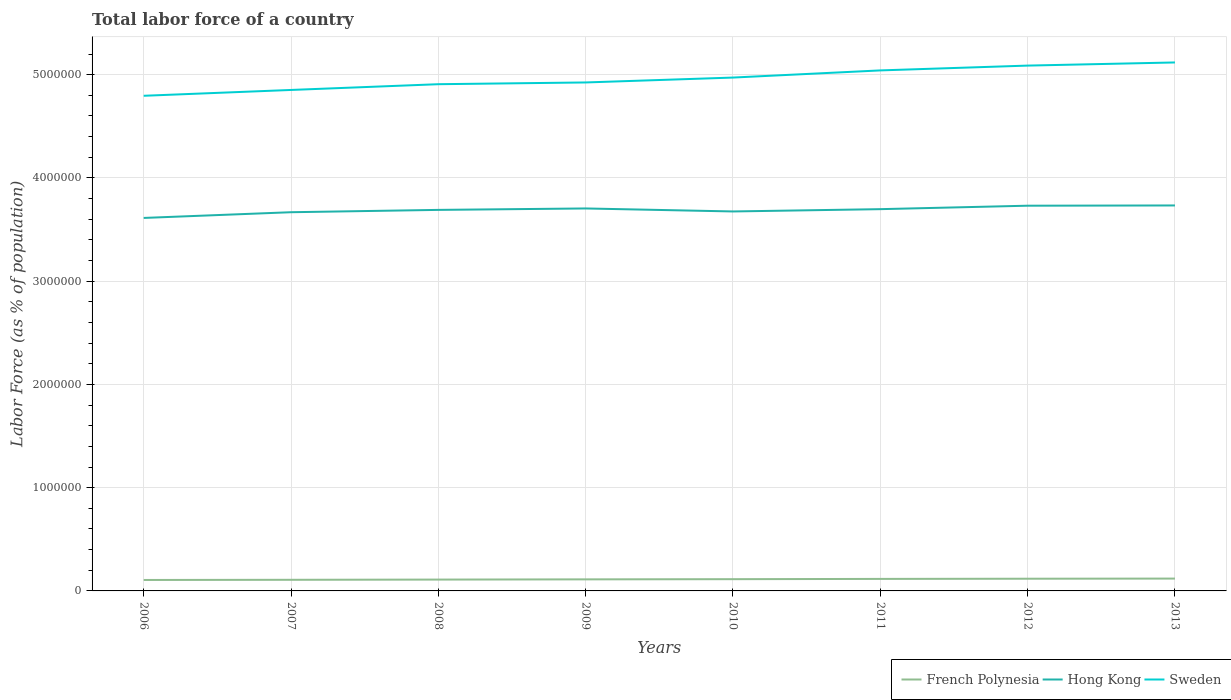How many different coloured lines are there?
Your response must be concise. 3. Does the line corresponding to French Polynesia intersect with the line corresponding to Sweden?
Provide a short and direct response. No. Across all years, what is the maximum percentage of labor force in French Polynesia?
Your response must be concise. 1.06e+05. What is the total percentage of labor force in Hong Kong in the graph?
Make the answer very short. -2.21e+04. What is the difference between the highest and the second highest percentage of labor force in French Polynesia?
Your response must be concise. 1.34e+04. Is the percentage of labor force in Sweden strictly greater than the percentage of labor force in French Polynesia over the years?
Give a very brief answer. No. Does the graph contain any zero values?
Provide a short and direct response. No. Does the graph contain grids?
Offer a terse response. Yes. Where does the legend appear in the graph?
Give a very brief answer. Bottom right. What is the title of the graph?
Provide a short and direct response. Total labor force of a country. What is the label or title of the Y-axis?
Give a very brief answer. Labor Force (as % of population). What is the Labor Force (as % of population) of French Polynesia in 2006?
Your answer should be very brief. 1.06e+05. What is the Labor Force (as % of population) of Hong Kong in 2006?
Your response must be concise. 3.61e+06. What is the Labor Force (as % of population) in Sweden in 2006?
Provide a short and direct response. 4.80e+06. What is the Labor Force (as % of population) in French Polynesia in 2007?
Ensure brevity in your answer.  1.08e+05. What is the Labor Force (as % of population) of Hong Kong in 2007?
Your response must be concise. 3.67e+06. What is the Labor Force (as % of population) of Sweden in 2007?
Give a very brief answer. 4.85e+06. What is the Labor Force (as % of population) of French Polynesia in 2008?
Offer a very short reply. 1.10e+05. What is the Labor Force (as % of population) in Hong Kong in 2008?
Provide a short and direct response. 3.69e+06. What is the Labor Force (as % of population) in Sweden in 2008?
Make the answer very short. 4.91e+06. What is the Labor Force (as % of population) of French Polynesia in 2009?
Your answer should be very brief. 1.12e+05. What is the Labor Force (as % of population) in Hong Kong in 2009?
Provide a short and direct response. 3.70e+06. What is the Labor Force (as % of population) of Sweden in 2009?
Provide a succinct answer. 4.92e+06. What is the Labor Force (as % of population) in French Polynesia in 2010?
Keep it short and to the point. 1.14e+05. What is the Labor Force (as % of population) of Hong Kong in 2010?
Make the answer very short. 3.68e+06. What is the Labor Force (as % of population) of Sweden in 2010?
Your answer should be very brief. 4.97e+06. What is the Labor Force (as % of population) of French Polynesia in 2011?
Your answer should be very brief. 1.16e+05. What is the Labor Force (as % of population) in Hong Kong in 2011?
Offer a very short reply. 3.70e+06. What is the Labor Force (as % of population) in Sweden in 2011?
Provide a short and direct response. 5.04e+06. What is the Labor Force (as % of population) of French Polynesia in 2012?
Provide a succinct answer. 1.18e+05. What is the Labor Force (as % of population) in Hong Kong in 2012?
Your answer should be compact. 3.73e+06. What is the Labor Force (as % of population) in Sweden in 2012?
Provide a short and direct response. 5.09e+06. What is the Labor Force (as % of population) of French Polynesia in 2013?
Provide a succinct answer. 1.20e+05. What is the Labor Force (as % of population) in Hong Kong in 2013?
Your answer should be very brief. 3.73e+06. What is the Labor Force (as % of population) in Sweden in 2013?
Provide a short and direct response. 5.12e+06. Across all years, what is the maximum Labor Force (as % of population) of French Polynesia?
Provide a succinct answer. 1.20e+05. Across all years, what is the maximum Labor Force (as % of population) in Hong Kong?
Give a very brief answer. 3.73e+06. Across all years, what is the maximum Labor Force (as % of population) of Sweden?
Provide a short and direct response. 5.12e+06. Across all years, what is the minimum Labor Force (as % of population) in French Polynesia?
Make the answer very short. 1.06e+05. Across all years, what is the minimum Labor Force (as % of population) in Hong Kong?
Provide a succinct answer. 3.61e+06. Across all years, what is the minimum Labor Force (as % of population) of Sweden?
Offer a terse response. 4.80e+06. What is the total Labor Force (as % of population) of French Polynesia in the graph?
Give a very brief answer. 9.04e+05. What is the total Labor Force (as % of population) of Hong Kong in the graph?
Your answer should be compact. 2.95e+07. What is the total Labor Force (as % of population) in Sweden in the graph?
Make the answer very short. 3.97e+07. What is the difference between the Labor Force (as % of population) in French Polynesia in 2006 and that in 2007?
Provide a short and direct response. -1577. What is the difference between the Labor Force (as % of population) in Hong Kong in 2006 and that in 2007?
Provide a short and direct response. -5.53e+04. What is the difference between the Labor Force (as % of population) of Sweden in 2006 and that in 2007?
Your answer should be compact. -5.64e+04. What is the difference between the Labor Force (as % of population) of French Polynesia in 2006 and that in 2008?
Offer a terse response. -3762. What is the difference between the Labor Force (as % of population) in Hong Kong in 2006 and that in 2008?
Offer a terse response. -7.80e+04. What is the difference between the Labor Force (as % of population) of Sweden in 2006 and that in 2008?
Your response must be concise. -1.12e+05. What is the difference between the Labor Force (as % of population) in French Polynesia in 2006 and that in 2009?
Ensure brevity in your answer.  -5846. What is the difference between the Labor Force (as % of population) in Hong Kong in 2006 and that in 2009?
Your response must be concise. -9.18e+04. What is the difference between the Labor Force (as % of population) in Sweden in 2006 and that in 2009?
Your response must be concise. -1.29e+05. What is the difference between the Labor Force (as % of population) in French Polynesia in 2006 and that in 2010?
Provide a short and direct response. -7704. What is the difference between the Labor Force (as % of population) of Hong Kong in 2006 and that in 2010?
Provide a short and direct response. -6.29e+04. What is the difference between the Labor Force (as % of population) in Sweden in 2006 and that in 2010?
Keep it short and to the point. -1.76e+05. What is the difference between the Labor Force (as % of population) in French Polynesia in 2006 and that in 2011?
Ensure brevity in your answer.  -1.03e+04. What is the difference between the Labor Force (as % of population) of Hong Kong in 2006 and that in 2011?
Offer a terse response. -8.50e+04. What is the difference between the Labor Force (as % of population) in Sweden in 2006 and that in 2011?
Your answer should be compact. -2.46e+05. What is the difference between the Labor Force (as % of population) of French Polynesia in 2006 and that in 2012?
Offer a very short reply. -1.20e+04. What is the difference between the Labor Force (as % of population) of Hong Kong in 2006 and that in 2012?
Give a very brief answer. -1.18e+05. What is the difference between the Labor Force (as % of population) of Sweden in 2006 and that in 2012?
Give a very brief answer. -2.92e+05. What is the difference between the Labor Force (as % of population) of French Polynesia in 2006 and that in 2013?
Offer a very short reply. -1.34e+04. What is the difference between the Labor Force (as % of population) in Hong Kong in 2006 and that in 2013?
Provide a succinct answer. -1.21e+05. What is the difference between the Labor Force (as % of population) of Sweden in 2006 and that in 2013?
Make the answer very short. -3.23e+05. What is the difference between the Labor Force (as % of population) of French Polynesia in 2007 and that in 2008?
Your answer should be compact. -2185. What is the difference between the Labor Force (as % of population) in Hong Kong in 2007 and that in 2008?
Ensure brevity in your answer.  -2.26e+04. What is the difference between the Labor Force (as % of population) of Sweden in 2007 and that in 2008?
Give a very brief answer. -5.57e+04. What is the difference between the Labor Force (as % of population) of French Polynesia in 2007 and that in 2009?
Give a very brief answer. -4269. What is the difference between the Labor Force (as % of population) in Hong Kong in 2007 and that in 2009?
Your response must be concise. -3.65e+04. What is the difference between the Labor Force (as % of population) of Sweden in 2007 and that in 2009?
Provide a succinct answer. -7.26e+04. What is the difference between the Labor Force (as % of population) of French Polynesia in 2007 and that in 2010?
Offer a terse response. -6127. What is the difference between the Labor Force (as % of population) in Hong Kong in 2007 and that in 2010?
Your answer should be very brief. -7529. What is the difference between the Labor Force (as % of population) of Sweden in 2007 and that in 2010?
Offer a very short reply. -1.20e+05. What is the difference between the Labor Force (as % of population) of French Polynesia in 2007 and that in 2011?
Your response must be concise. -8724. What is the difference between the Labor Force (as % of population) of Hong Kong in 2007 and that in 2011?
Give a very brief answer. -2.97e+04. What is the difference between the Labor Force (as % of population) in Sweden in 2007 and that in 2011?
Your answer should be very brief. -1.89e+05. What is the difference between the Labor Force (as % of population) of French Polynesia in 2007 and that in 2012?
Your answer should be very brief. -1.05e+04. What is the difference between the Labor Force (as % of population) of Hong Kong in 2007 and that in 2012?
Your answer should be compact. -6.31e+04. What is the difference between the Labor Force (as % of population) in Sweden in 2007 and that in 2012?
Offer a very short reply. -2.36e+05. What is the difference between the Labor Force (as % of population) in French Polynesia in 2007 and that in 2013?
Offer a terse response. -1.18e+04. What is the difference between the Labor Force (as % of population) in Hong Kong in 2007 and that in 2013?
Keep it short and to the point. -6.55e+04. What is the difference between the Labor Force (as % of population) in Sweden in 2007 and that in 2013?
Keep it short and to the point. -2.66e+05. What is the difference between the Labor Force (as % of population) in French Polynesia in 2008 and that in 2009?
Offer a very short reply. -2084. What is the difference between the Labor Force (as % of population) in Hong Kong in 2008 and that in 2009?
Ensure brevity in your answer.  -1.39e+04. What is the difference between the Labor Force (as % of population) of Sweden in 2008 and that in 2009?
Ensure brevity in your answer.  -1.69e+04. What is the difference between the Labor Force (as % of population) in French Polynesia in 2008 and that in 2010?
Provide a short and direct response. -3942. What is the difference between the Labor Force (as % of population) in Hong Kong in 2008 and that in 2010?
Offer a very short reply. 1.51e+04. What is the difference between the Labor Force (as % of population) of Sweden in 2008 and that in 2010?
Give a very brief answer. -6.44e+04. What is the difference between the Labor Force (as % of population) of French Polynesia in 2008 and that in 2011?
Keep it short and to the point. -6539. What is the difference between the Labor Force (as % of population) in Hong Kong in 2008 and that in 2011?
Provide a succinct answer. -7041. What is the difference between the Labor Force (as % of population) in Sweden in 2008 and that in 2011?
Your answer should be very brief. -1.34e+05. What is the difference between the Labor Force (as % of population) in French Polynesia in 2008 and that in 2012?
Give a very brief answer. -8269. What is the difference between the Labor Force (as % of population) in Hong Kong in 2008 and that in 2012?
Give a very brief answer. -4.05e+04. What is the difference between the Labor Force (as % of population) in Sweden in 2008 and that in 2012?
Your response must be concise. -1.80e+05. What is the difference between the Labor Force (as % of population) of French Polynesia in 2008 and that in 2013?
Your response must be concise. -9644. What is the difference between the Labor Force (as % of population) in Hong Kong in 2008 and that in 2013?
Your response must be concise. -4.29e+04. What is the difference between the Labor Force (as % of population) of Sweden in 2008 and that in 2013?
Make the answer very short. -2.11e+05. What is the difference between the Labor Force (as % of population) of French Polynesia in 2009 and that in 2010?
Make the answer very short. -1858. What is the difference between the Labor Force (as % of population) in Hong Kong in 2009 and that in 2010?
Your answer should be very brief. 2.90e+04. What is the difference between the Labor Force (as % of population) in Sweden in 2009 and that in 2010?
Your answer should be very brief. -4.74e+04. What is the difference between the Labor Force (as % of population) of French Polynesia in 2009 and that in 2011?
Offer a very short reply. -4455. What is the difference between the Labor Force (as % of population) in Hong Kong in 2009 and that in 2011?
Provide a succinct answer. 6847. What is the difference between the Labor Force (as % of population) in Sweden in 2009 and that in 2011?
Offer a very short reply. -1.17e+05. What is the difference between the Labor Force (as % of population) in French Polynesia in 2009 and that in 2012?
Make the answer very short. -6185. What is the difference between the Labor Force (as % of population) in Hong Kong in 2009 and that in 2012?
Make the answer very short. -2.66e+04. What is the difference between the Labor Force (as % of population) of Sweden in 2009 and that in 2012?
Your answer should be compact. -1.63e+05. What is the difference between the Labor Force (as % of population) in French Polynesia in 2009 and that in 2013?
Give a very brief answer. -7560. What is the difference between the Labor Force (as % of population) in Hong Kong in 2009 and that in 2013?
Make the answer very short. -2.90e+04. What is the difference between the Labor Force (as % of population) of Sweden in 2009 and that in 2013?
Keep it short and to the point. -1.94e+05. What is the difference between the Labor Force (as % of population) of French Polynesia in 2010 and that in 2011?
Ensure brevity in your answer.  -2597. What is the difference between the Labor Force (as % of population) of Hong Kong in 2010 and that in 2011?
Your answer should be very brief. -2.21e+04. What is the difference between the Labor Force (as % of population) in Sweden in 2010 and that in 2011?
Provide a succinct answer. -6.93e+04. What is the difference between the Labor Force (as % of population) of French Polynesia in 2010 and that in 2012?
Provide a short and direct response. -4327. What is the difference between the Labor Force (as % of population) of Hong Kong in 2010 and that in 2012?
Provide a short and direct response. -5.56e+04. What is the difference between the Labor Force (as % of population) of Sweden in 2010 and that in 2012?
Offer a terse response. -1.16e+05. What is the difference between the Labor Force (as % of population) in French Polynesia in 2010 and that in 2013?
Provide a succinct answer. -5702. What is the difference between the Labor Force (as % of population) of Hong Kong in 2010 and that in 2013?
Keep it short and to the point. -5.80e+04. What is the difference between the Labor Force (as % of population) of Sweden in 2010 and that in 2013?
Make the answer very short. -1.46e+05. What is the difference between the Labor Force (as % of population) in French Polynesia in 2011 and that in 2012?
Your answer should be compact. -1730. What is the difference between the Labor Force (as % of population) in Hong Kong in 2011 and that in 2012?
Offer a very short reply. -3.34e+04. What is the difference between the Labor Force (as % of population) in Sweden in 2011 and that in 2012?
Provide a short and direct response. -4.66e+04. What is the difference between the Labor Force (as % of population) in French Polynesia in 2011 and that in 2013?
Ensure brevity in your answer.  -3105. What is the difference between the Labor Force (as % of population) of Hong Kong in 2011 and that in 2013?
Give a very brief answer. -3.59e+04. What is the difference between the Labor Force (as % of population) of Sweden in 2011 and that in 2013?
Ensure brevity in your answer.  -7.70e+04. What is the difference between the Labor Force (as % of population) in French Polynesia in 2012 and that in 2013?
Offer a very short reply. -1375. What is the difference between the Labor Force (as % of population) in Hong Kong in 2012 and that in 2013?
Provide a short and direct response. -2418. What is the difference between the Labor Force (as % of population) in Sweden in 2012 and that in 2013?
Offer a terse response. -3.05e+04. What is the difference between the Labor Force (as % of population) in French Polynesia in 2006 and the Labor Force (as % of population) in Hong Kong in 2007?
Keep it short and to the point. -3.56e+06. What is the difference between the Labor Force (as % of population) of French Polynesia in 2006 and the Labor Force (as % of population) of Sweden in 2007?
Offer a terse response. -4.75e+06. What is the difference between the Labor Force (as % of population) in Hong Kong in 2006 and the Labor Force (as % of population) in Sweden in 2007?
Offer a terse response. -1.24e+06. What is the difference between the Labor Force (as % of population) of French Polynesia in 2006 and the Labor Force (as % of population) of Hong Kong in 2008?
Provide a succinct answer. -3.58e+06. What is the difference between the Labor Force (as % of population) in French Polynesia in 2006 and the Labor Force (as % of population) in Sweden in 2008?
Ensure brevity in your answer.  -4.80e+06. What is the difference between the Labor Force (as % of population) in Hong Kong in 2006 and the Labor Force (as % of population) in Sweden in 2008?
Give a very brief answer. -1.30e+06. What is the difference between the Labor Force (as % of population) in French Polynesia in 2006 and the Labor Force (as % of population) in Hong Kong in 2009?
Your response must be concise. -3.60e+06. What is the difference between the Labor Force (as % of population) of French Polynesia in 2006 and the Labor Force (as % of population) of Sweden in 2009?
Give a very brief answer. -4.82e+06. What is the difference between the Labor Force (as % of population) in Hong Kong in 2006 and the Labor Force (as % of population) in Sweden in 2009?
Give a very brief answer. -1.31e+06. What is the difference between the Labor Force (as % of population) of French Polynesia in 2006 and the Labor Force (as % of population) of Hong Kong in 2010?
Your response must be concise. -3.57e+06. What is the difference between the Labor Force (as % of population) of French Polynesia in 2006 and the Labor Force (as % of population) of Sweden in 2010?
Your answer should be compact. -4.87e+06. What is the difference between the Labor Force (as % of population) in Hong Kong in 2006 and the Labor Force (as % of population) in Sweden in 2010?
Keep it short and to the point. -1.36e+06. What is the difference between the Labor Force (as % of population) of French Polynesia in 2006 and the Labor Force (as % of population) of Hong Kong in 2011?
Your answer should be compact. -3.59e+06. What is the difference between the Labor Force (as % of population) of French Polynesia in 2006 and the Labor Force (as % of population) of Sweden in 2011?
Keep it short and to the point. -4.94e+06. What is the difference between the Labor Force (as % of population) of Hong Kong in 2006 and the Labor Force (as % of population) of Sweden in 2011?
Offer a terse response. -1.43e+06. What is the difference between the Labor Force (as % of population) in French Polynesia in 2006 and the Labor Force (as % of population) in Hong Kong in 2012?
Your answer should be very brief. -3.62e+06. What is the difference between the Labor Force (as % of population) of French Polynesia in 2006 and the Labor Force (as % of population) of Sweden in 2012?
Make the answer very short. -4.98e+06. What is the difference between the Labor Force (as % of population) of Hong Kong in 2006 and the Labor Force (as % of population) of Sweden in 2012?
Make the answer very short. -1.48e+06. What is the difference between the Labor Force (as % of population) of French Polynesia in 2006 and the Labor Force (as % of population) of Hong Kong in 2013?
Ensure brevity in your answer.  -3.63e+06. What is the difference between the Labor Force (as % of population) in French Polynesia in 2006 and the Labor Force (as % of population) in Sweden in 2013?
Offer a very short reply. -5.01e+06. What is the difference between the Labor Force (as % of population) in Hong Kong in 2006 and the Labor Force (as % of population) in Sweden in 2013?
Make the answer very short. -1.51e+06. What is the difference between the Labor Force (as % of population) in French Polynesia in 2007 and the Labor Force (as % of population) in Hong Kong in 2008?
Give a very brief answer. -3.58e+06. What is the difference between the Labor Force (as % of population) in French Polynesia in 2007 and the Labor Force (as % of population) in Sweden in 2008?
Make the answer very short. -4.80e+06. What is the difference between the Labor Force (as % of population) of Hong Kong in 2007 and the Labor Force (as % of population) of Sweden in 2008?
Keep it short and to the point. -1.24e+06. What is the difference between the Labor Force (as % of population) in French Polynesia in 2007 and the Labor Force (as % of population) in Hong Kong in 2009?
Make the answer very short. -3.60e+06. What is the difference between the Labor Force (as % of population) of French Polynesia in 2007 and the Labor Force (as % of population) of Sweden in 2009?
Ensure brevity in your answer.  -4.82e+06. What is the difference between the Labor Force (as % of population) of Hong Kong in 2007 and the Labor Force (as % of population) of Sweden in 2009?
Offer a terse response. -1.26e+06. What is the difference between the Labor Force (as % of population) of French Polynesia in 2007 and the Labor Force (as % of population) of Hong Kong in 2010?
Give a very brief answer. -3.57e+06. What is the difference between the Labor Force (as % of population) of French Polynesia in 2007 and the Labor Force (as % of population) of Sweden in 2010?
Provide a short and direct response. -4.86e+06. What is the difference between the Labor Force (as % of population) of Hong Kong in 2007 and the Labor Force (as % of population) of Sweden in 2010?
Provide a succinct answer. -1.30e+06. What is the difference between the Labor Force (as % of population) of French Polynesia in 2007 and the Labor Force (as % of population) of Hong Kong in 2011?
Offer a terse response. -3.59e+06. What is the difference between the Labor Force (as % of population) in French Polynesia in 2007 and the Labor Force (as % of population) in Sweden in 2011?
Your answer should be very brief. -4.93e+06. What is the difference between the Labor Force (as % of population) of Hong Kong in 2007 and the Labor Force (as % of population) of Sweden in 2011?
Provide a short and direct response. -1.37e+06. What is the difference between the Labor Force (as % of population) in French Polynesia in 2007 and the Labor Force (as % of population) in Hong Kong in 2012?
Give a very brief answer. -3.62e+06. What is the difference between the Labor Force (as % of population) in French Polynesia in 2007 and the Labor Force (as % of population) in Sweden in 2012?
Your answer should be compact. -4.98e+06. What is the difference between the Labor Force (as % of population) in Hong Kong in 2007 and the Labor Force (as % of population) in Sweden in 2012?
Offer a very short reply. -1.42e+06. What is the difference between the Labor Force (as % of population) in French Polynesia in 2007 and the Labor Force (as % of population) in Hong Kong in 2013?
Your response must be concise. -3.63e+06. What is the difference between the Labor Force (as % of population) of French Polynesia in 2007 and the Labor Force (as % of population) of Sweden in 2013?
Provide a succinct answer. -5.01e+06. What is the difference between the Labor Force (as % of population) in Hong Kong in 2007 and the Labor Force (as % of population) in Sweden in 2013?
Offer a terse response. -1.45e+06. What is the difference between the Labor Force (as % of population) of French Polynesia in 2008 and the Labor Force (as % of population) of Hong Kong in 2009?
Ensure brevity in your answer.  -3.59e+06. What is the difference between the Labor Force (as % of population) of French Polynesia in 2008 and the Labor Force (as % of population) of Sweden in 2009?
Provide a succinct answer. -4.81e+06. What is the difference between the Labor Force (as % of population) of Hong Kong in 2008 and the Labor Force (as % of population) of Sweden in 2009?
Your answer should be very brief. -1.23e+06. What is the difference between the Labor Force (as % of population) in French Polynesia in 2008 and the Labor Force (as % of population) in Hong Kong in 2010?
Offer a terse response. -3.57e+06. What is the difference between the Labor Force (as % of population) in French Polynesia in 2008 and the Labor Force (as % of population) in Sweden in 2010?
Provide a short and direct response. -4.86e+06. What is the difference between the Labor Force (as % of population) in Hong Kong in 2008 and the Labor Force (as % of population) in Sweden in 2010?
Your response must be concise. -1.28e+06. What is the difference between the Labor Force (as % of population) of French Polynesia in 2008 and the Labor Force (as % of population) of Hong Kong in 2011?
Provide a short and direct response. -3.59e+06. What is the difference between the Labor Force (as % of population) in French Polynesia in 2008 and the Labor Force (as % of population) in Sweden in 2011?
Make the answer very short. -4.93e+06. What is the difference between the Labor Force (as % of population) in Hong Kong in 2008 and the Labor Force (as % of population) in Sweden in 2011?
Make the answer very short. -1.35e+06. What is the difference between the Labor Force (as % of population) of French Polynesia in 2008 and the Labor Force (as % of population) of Hong Kong in 2012?
Your answer should be compact. -3.62e+06. What is the difference between the Labor Force (as % of population) of French Polynesia in 2008 and the Labor Force (as % of population) of Sweden in 2012?
Give a very brief answer. -4.98e+06. What is the difference between the Labor Force (as % of population) of Hong Kong in 2008 and the Labor Force (as % of population) of Sweden in 2012?
Offer a terse response. -1.40e+06. What is the difference between the Labor Force (as % of population) of French Polynesia in 2008 and the Labor Force (as % of population) of Hong Kong in 2013?
Your answer should be very brief. -3.62e+06. What is the difference between the Labor Force (as % of population) of French Polynesia in 2008 and the Labor Force (as % of population) of Sweden in 2013?
Make the answer very short. -5.01e+06. What is the difference between the Labor Force (as % of population) of Hong Kong in 2008 and the Labor Force (as % of population) of Sweden in 2013?
Give a very brief answer. -1.43e+06. What is the difference between the Labor Force (as % of population) in French Polynesia in 2009 and the Labor Force (as % of population) in Hong Kong in 2010?
Give a very brief answer. -3.56e+06. What is the difference between the Labor Force (as % of population) of French Polynesia in 2009 and the Labor Force (as % of population) of Sweden in 2010?
Provide a succinct answer. -4.86e+06. What is the difference between the Labor Force (as % of population) in Hong Kong in 2009 and the Labor Force (as % of population) in Sweden in 2010?
Your answer should be compact. -1.27e+06. What is the difference between the Labor Force (as % of population) in French Polynesia in 2009 and the Labor Force (as % of population) in Hong Kong in 2011?
Keep it short and to the point. -3.59e+06. What is the difference between the Labor Force (as % of population) of French Polynesia in 2009 and the Labor Force (as % of population) of Sweden in 2011?
Make the answer very short. -4.93e+06. What is the difference between the Labor Force (as % of population) in Hong Kong in 2009 and the Labor Force (as % of population) in Sweden in 2011?
Your response must be concise. -1.34e+06. What is the difference between the Labor Force (as % of population) of French Polynesia in 2009 and the Labor Force (as % of population) of Hong Kong in 2012?
Offer a terse response. -3.62e+06. What is the difference between the Labor Force (as % of population) in French Polynesia in 2009 and the Labor Force (as % of population) in Sweden in 2012?
Offer a terse response. -4.98e+06. What is the difference between the Labor Force (as % of population) in Hong Kong in 2009 and the Labor Force (as % of population) in Sweden in 2012?
Provide a succinct answer. -1.38e+06. What is the difference between the Labor Force (as % of population) in French Polynesia in 2009 and the Labor Force (as % of population) in Hong Kong in 2013?
Provide a succinct answer. -3.62e+06. What is the difference between the Labor Force (as % of population) in French Polynesia in 2009 and the Labor Force (as % of population) in Sweden in 2013?
Ensure brevity in your answer.  -5.01e+06. What is the difference between the Labor Force (as % of population) of Hong Kong in 2009 and the Labor Force (as % of population) of Sweden in 2013?
Provide a succinct answer. -1.41e+06. What is the difference between the Labor Force (as % of population) of French Polynesia in 2010 and the Labor Force (as % of population) of Hong Kong in 2011?
Your answer should be compact. -3.58e+06. What is the difference between the Labor Force (as % of population) of French Polynesia in 2010 and the Labor Force (as % of population) of Sweden in 2011?
Provide a succinct answer. -4.93e+06. What is the difference between the Labor Force (as % of population) in Hong Kong in 2010 and the Labor Force (as % of population) in Sweden in 2011?
Offer a terse response. -1.37e+06. What is the difference between the Labor Force (as % of population) of French Polynesia in 2010 and the Labor Force (as % of population) of Hong Kong in 2012?
Keep it short and to the point. -3.62e+06. What is the difference between the Labor Force (as % of population) of French Polynesia in 2010 and the Labor Force (as % of population) of Sweden in 2012?
Provide a short and direct response. -4.97e+06. What is the difference between the Labor Force (as % of population) of Hong Kong in 2010 and the Labor Force (as % of population) of Sweden in 2012?
Ensure brevity in your answer.  -1.41e+06. What is the difference between the Labor Force (as % of population) in French Polynesia in 2010 and the Labor Force (as % of population) in Hong Kong in 2013?
Provide a short and direct response. -3.62e+06. What is the difference between the Labor Force (as % of population) of French Polynesia in 2010 and the Labor Force (as % of population) of Sweden in 2013?
Keep it short and to the point. -5.00e+06. What is the difference between the Labor Force (as % of population) of Hong Kong in 2010 and the Labor Force (as % of population) of Sweden in 2013?
Provide a succinct answer. -1.44e+06. What is the difference between the Labor Force (as % of population) of French Polynesia in 2011 and the Labor Force (as % of population) of Hong Kong in 2012?
Keep it short and to the point. -3.61e+06. What is the difference between the Labor Force (as % of population) in French Polynesia in 2011 and the Labor Force (as % of population) in Sweden in 2012?
Your answer should be compact. -4.97e+06. What is the difference between the Labor Force (as % of population) in Hong Kong in 2011 and the Labor Force (as % of population) in Sweden in 2012?
Provide a succinct answer. -1.39e+06. What is the difference between the Labor Force (as % of population) of French Polynesia in 2011 and the Labor Force (as % of population) of Hong Kong in 2013?
Give a very brief answer. -3.62e+06. What is the difference between the Labor Force (as % of population) of French Polynesia in 2011 and the Labor Force (as % of population) of Sweden in 2013?
Provide a succinct answer. -5.00e+06. What is the difference between the Labor Force (as % of population) in Hong Kong in 2011 and the Labor Force (as % of population) in Sweden in 2013?
Offer a very short reply. -1.42e+06. What is the difference between the Labor Force (as % of population) of French Polynesia in 2012 and the Labor Force (as % of population) of Hong Kong in 2013?
Your answer should be very brief. -3.62e+06. What is the difference between the Labor Force (as % of population) in French Polynesia in 2012 and the Labor Force (as % of population) in Sweden in 2013?
Your response must be concise. -5.00e+06. What is the difference between the Labor Force (as % of population) of Hong Kong in 2012 and the Labor Force (as % of population) of Sweden in 2013?
Your answer should be very brief. -1.39e+06. What is the average Labor Force (as % of population) of French Polynesia per year?
Ensure brevity in your answer.  1.13e+05. What is the average Labor Force (as % of population) in Hong Kong per year?
Your answer should be very brief. 3.69e+06. What is the average Labor Force (as % of population) of Sweden per year?
Keep it short and to the point. 4.96e+06. In the year 2006, what is the difference between the Labor Force (as % of population) in French Polynesia and Labor Force (as % of population) in Hong Kong?
Provide a short and direct response. -3.51e+06. In the year 2006, what is the difference between the Labor Force (as % of population) in French Polynesia and Labor Force (as % of population) in Sweden?
Offer a terse response. -4.69e+06. In the year 2006, what is the difference between the Labor Force (as % of population) in Hong Kong and Labor Force (as % of population) in Sweden?
Keep it short and to the point. -1.18e+06. In the year 2007, what is the difference between the Labor Force (as % of population) of French Polynesia and Labor Force (as % of population) of Hong Kong?
Your response must be concise. -3.56e+06. In the year 2007, what is the difference between the Labor Force (as % of population) in French Polynesia and Labor Force (as % of population) in Sweden?
Provide a short and direct response. -4.74e+06. In the year 2007, what is the difference between the Labor Force (as % of population) of Hong Kong and Labor Force (as % of population) of Sweden?
Keep it short and to the point. -1.18e+06. In the year 2008, what is the difference between the Labor Force (as % of population) in French Polynesia and Labor Force (as % of population) in Hong Kong?
Your response must be concise. -3.58e+06. In the year 2008, what is the difference between the Labor Force (as % of population) in French Polynesia and Labor Force (as % of population) in Sweden?
Offer a very short reply. -4.80e+06. In the year 2008, what is the difference between the Labor Force (as % of population) in Hong Kong and Labor Force (as % of population) in Sweden?
Provide a short and direct response. -1.22e+06. In the year 2009, what is the difference between the Labor Force (as % of population) in French Polynesia and Labor Force (as % of population) in Hong Kong?
Provide a succinct answer. -3.59e+06. In the year 2009, what is the difference between the Labor Force (as % of population) of French Polynesia and Labor Force (as % of population) of Sweden?
Offer a very short reply. -4.81e+06. In the year 2009, what is the difference between the Labor Force (as % of population) in Hong Kong and Labor Force (as % of population) in Sweden?
Provide a short and direct response. -1.22e+06. In the year 2010, what is the difference between the Labor Force (as % of population) of French Polynesia and Labor Force (as % of population) of Hong Kong?
Offer a very short reply. -3.56e+06. In the year 2010, what is the difference between the Labor Force (as % of population) of French Polynesia and Labor Force (as % of population) of Sweden?
Your answer should be very brief. -4.86e+06. In the year 2010, what is the difference between the Labor Force (as % of population) in Hong Kong and Labor Force (as % of population) in Sweden?
Offer a terse response. -1.30e+06. In the year 2011, what is the difference between the Labor Force (as % of population) of French Polynesia and Labor Force (as % of population) of Hong Kong?
Your answer should be very brief. -3.58e+06. In the year 2011, what is the difference between the Labor Force (as % of population) of French Polynesia and Labor Force (as % of population) of Sweden?
Offer a terse response. -4.92e+06. In the year 2011, what is the difference between the Labor Force (as % of population) in Hong Kong and Labor Force (as % of population) in Sweden?
Make the answer very short. -1.34e+06. In the year 2012, what is the difference between the Labor Force (as % of population) in French Polynesia and Labor Force (as % of population) in Hong Kong?
Ensure brevity in your answer.  -3.61e+06. In the year 2012, what is the difference between the Labor Force (as % of population) in French Polynesia and Labor Force (as % of population) in Sweden?
Your answer should be very brief. -4.97e+06. In the year 2012, what is the difference between the Labor Force (as % of population) of Hong Kong and Labor Force (as % of population) of Sweden?
Your answer should be compact. -1.36e+06. In the year 2013, what is the difference between the Labor Force (as % of population) of French Polynesia and Labor Force (as % of population) of Hong Kong?
Your answer should be very brief. -3.61e+06. In the year 2013, what is the difference between the Labor Force (as % of population) of French Polynesia and Labor Force (as % of population) of Sweden?
Provide a short and direct response. -5.00e+06. In the year 2013, what is the difference between the Labor Force (as % of population) in Hong Kong and Labor Force (as % of population) in Sweden?
Make the answer very short. -1.39e+06. What is the ratio of the Labor Force (as % of population) in French Polynesia in 2006 to that in 2007?
Ensure brevity in your answer.  0.99. What is the ratio of the Labor Force (as % of population) in Hong Kong in 2006 to that in 2007?
Your answer should be compact. 0.98. What is the ratio of the Labor Force (as % of population) of Sweden in 2006 to that in 2007?
Make the answer very short. 0.99. What is the ratio of the Labor Force (as % of population) in French Polynesia in 2006 to that in 2008?
Ensure brevity in your answer.  0.97. What is the ratio of the Labor Force (as % of population) in Hong Kong in 2006 to that in 2008?
Make the answer very short. 0.98. What is the ratio of the Labor Force (as % of population) of Sweden in 2006 to that in 2008?
Give a very brief answer. 0.98. What is the ratio of the Labor Force (as % of population) of French Polynesia in 2006 to that in 2009?
Your response must be concise. 0.95. What is the ratio of the Labor Force (as % of population) of Hong Kong in 2006 to that in 2009?
Provide a short and direct response. 0.98. What is the ratio of the Labor Force (as % of population) of Sweden in 2006 to that in 2009?
Make the answer very short. 0.97. What is the ratio of the Labor Force (as % of population) in French Polynesia in 2006 to that in 2010?
Keep it short and to the point. 0.93. What is the ratio of the Labor Force (as % of population) in Hong Kong in 2006 to that in 2010?
Your answer should be compact. 0.98. What is the ratio of the Labor Force (as % of population) of Sweden in 2006 to that in 2010?
Give a very brief answer. 0.96. What is the ratio of the Labor Force (as % of population) in French Polynesia in 2006 to that in 2011?
Provide a short and direct response. 0.91. What is the ratio of the Labor Force (as % of population) of Sweden in 2006 to that in 2011?
Keep it short and to the point. 0.95. What is the ratio of the Labor Force (as % of population) of French Polynesia in 2006 to that in 2012?
Keep it short and to the point. 0.9. What is the ratio of the Labor Force (as % of population) of Hong Kong in 2006 to that in 2012?
Ensure brevity in your answer.  0.97. What is the ratio of the Labor Force (as % of population) in Sweden in 2006 to that in 2012?
Provide a short and direct response. 0.94. What is the ratio of the Labor Force (as % of population) in French Polynesia in 2006 to that in 2013?
Provide a succinct answer. 0.89. What is the ratio of the Labor Force (as % of population) in Hong Kong in 2006 to that in 2013?
Keep it short and to the point. 0.97. What is the ratio of the Labor Force (as % of population) of Sweden in 2006 to that in 2013?
Offer a terse response. 0.94. What is the ratio of the Labor Force (as % of population) in French Polynesia in 2007 to that in 2008?
Give a very brief answer. 0.98. What is the ratio of the Labor Force (as % of population) of Sweden in 2007 to that in 2008?
Offer a terse response. 0.99. What is the ratio of the Labor Force (as % of population) of French Polynesia in 2007 to that in 2009?
Ensure brevity in your answer.  0.96. What is the ratio of the Labor Force (as % of population) of Sweden in 2007 to that in 2009?
Your answer should be very brief. 0.99. What is the ratio of the Labor Force (as % of population) in French Polynesia in 2007 to that in 2010?
Offer a terse response. 0.95. What is the ratio of the Labor Force (as % of population) of Sweden in 2007 to that in 2010?
Offer a very short reply. 0.98. What is the ratio of the Labor Force (as % of population) in French Polynesia in 2007 to that in 2011?
Offer a very short reply. 0.93. What is the ratio of the Labor Force (as % of population) in Sweden in 2007 to that in 2011?
Ensure brevity in your answer.  0.96. What is the ratio of the Labor Force (as % of population) in French Polynesia in 2007 to that in 2012?
Keep it short and to the point. 0.91. What is the ratio of the Labor Force (as % of population) of Hong Kong in 2007 to that in 2012?
Offer a very short reply. 0.98. What is the ratio of the Labor Force (as % of population) in Sweden in 2007 to that in 2012?
Provide a succinct answer. 0.95. What is the ratio of the Labor Force (as % of population) in French Polynesia in 2007 to that in 2013?
Make the answer very short. 0.9. What is the ratio of the Labor Force (as % of population) of Hong Kong in 2007 to that in 2013?
Your answer should be compact. 0.98. What is the ratio of the Labor Force (as % of population) in Sweden in 2007 to that in 2013?
Give a very brief answer. 0.95. What is the ratio of the Labor Force (as % of population) of French Polynesia in 2008 to that in 2009?
Keep it short and to the point. 0.98. What is the ratio of the Labor Force (as % of population) of Hong Kong in 2008 to that in 2009?
Make the answer very short. 1. What is the ratio of the Labor Force (as % of population) of French Polynesia in 2008 to that in 2010?
Your response must be concise. 0.97. What is the ratio of the Labor Force (as % of population) of Sweden in 2008 to that in 2010?
Your answer should be very brief. 0.99. What is the ratio of the Labor Force (as % of population) in French Polynesia in 2008 to that in 2011?
Ensure brevity in your answer.  0.94. What is the ratio of the Labor Force (as % of population) in Sweden in 2008 to that in 2011?
Give a very brief answer. 0.97. What is the ratio of the Labor Force (as % of population) of Hong Kong in 2008 to that in 2012?
Ensure brevity in your answer.  0.99. What is the ratio of the Labor Force (as % of population) of Sweden in 2008 to that in 2012?
Provide a succinct answer. 0.96. What is the ratio of the Labor Force (as % of population) in French Polynesia in 2008 to that in 2013?
Keep it short and to the point. 0.92. What is the ratio of the Labor Force (as % of population) of Sweden in 2008 to that in 2013?
Your response must be concise. 0.96. What is the ratio of the Labor Force (as % of population) in French Polynesia in 2009 to that in 2010?
Offer a very short reply. 0.98. What is the ratio of the Labor Force (as % of population) of Hong Kong in 2009 to that in 2010?
Offer a terse response. 1.01. What is the ratio of the Labor Force (as % of population) of French Polynesia in 2009 to that in 2011?
Your answer should be compact. 0.96. What is the ratio of the Labor Force (as % of population) in Hong Kong in 2009 to that in 2011?
Provide a succinct answer. 1. What is the ratio of the Labor Force (as % of population) of Sweden in 2009 to that in 2011?
Your answer should be compact. 0.98. What is the ratio of the Labor Force (as % of population) in French Polynesia in 2009 to that in 2012?
Offer a very short reply. 0.95. What is the ratio of the Labor Force (as % of population) of Sweden in 2009 to that in 2012?
Make the answer very short. 0.97. What is the ratio of the Labor Force (as % of population) in French Polynesia in 2009 to that in 2013?
Offer a terse response. 0.94. What is the ratio of the Labor Force (as % of population) in Hong Kong in 2009 to that in 2013?
Offer a very short reply. 0.99. What is the ratio of the Labor Force (as % of population) in Sweden in 2009 to that in 2013?
Offer a terse response. 0.96. What is the ratio of the Labor Force (as % of population) of French Polynesia in 2010 to that in 2011?
Your answer should be compact. 0.98. What is the ratio of the Labor Force (as % of population) of Hong Kong in 2010 to that in 2011?
Ensure brevity in your answer.  0.99. What is the ratio of the Labor Force (as % of population) of Sweden in 2010 to that in 2011?
Give a very brief answer. 0.99. What is the ratio of the Labor Force (as % of population) in French Polynesia in 2010 to that in 2012?
Offer a very short reply. 0.96. What is the ratio of the Labor Force (as % of population) in Hong Kong in 2010 to that in 2012?
Offer a terse response. 0.99. What is the ratio of the Labor Force (as % of population) of Sweden in 2010 to that in 2012?
Keep it short and to the point. 0.98. What is the ratio of the Labor Force (as % of population) of French Polynesia in 2010 to that in 2013?
Your answer should be compact. 0.95. What is the ratio of the Labor Force (as % of population) in Hong Kong in 2010 to that in 2013?
Offer a terse response. 0.98. What is the ratio of the Labor Force (as % of population) of Sweden in 2010 to that in 2013?
Offer a very short reply. 0.97. What is the ratio of the Labor Force (as % of population) of French Polynesia in 2011 to that in 2012?
Ensure brevity in your answer.  0.99. What is the ratio of the Labor Force (as % of population) in Sweden in 2011 to that in 2012?
Keep it short and to the point. 0.99. What is the ratio of the Labor Force (as % of population) in Sweden in 2011 to that in 2013?
Offer a very short reply. 0.98. What is the ratio of the Labor Force (as % of population) of Hong Kong in 2012 to that in 2013?
Make the answer very short. 1. What is the ratio of the Labor Force (as % of population) in Sweden in 2012 to that in 2013?
Keep it short and to the point. 0.99. What is the difference between the highest and the second highest Labor Force (as % of population) in French Polynesia?
Offer a terse response. 1375. What is the difference between the highest and the second highest Labor Force (as % of population) of Hong Kong?
Offer a terse response. 2418. What is the difference between the highest and the second highest Labor Force (as % of population) in Sweden?
Your answer should be compact. 3.05e+04. What is the difference between the highest and the lowest Labor Force (as % of population) in French Polynesia?
Your answer should be compact. 1.34e+04. What is the difference between the highest and the lowest Labor Force (as % of population) in Hong Kong?
Provide a succinct answer. 1.21e+05. What is the difference between the highest and the lowest Labor Force (as % of population) in Sweden?
Keep it short and to the point. 3.23e+05. 